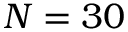Convert formula to latex. <formula><loc_0><loc_0><loc_500><loc_500>N = 3 0</formula> 